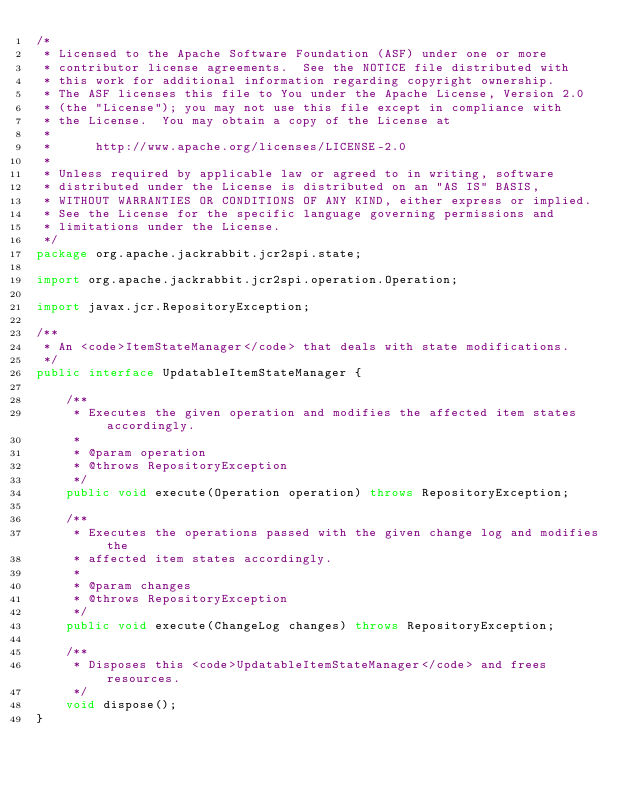Convert code to text. <code><loc_0><loc_0><loc_500><loc_500><_Java_>/*
 * Licensed to the Apache Software Foundation (ASF) under one or more
 * contributor license agreements.  See the NOTICE file distributed with
 * this work for additional information regarding copyright ownership.
 * The ASF licenses this file to You under the Apache License, Version 2.0
 * (the "License"); you may not use this file except in compliance with
 * the License.  You may obtain a copy of the License at
 *
 *      http://www.apache.org/licenses/LICENSE-2.0
 *
 * Unless required by applicable law or agreed to in writing, software
 * distributed under the License is distributed on an "AS IS" BASIS,
 * WITHOUT WARRANTIES OR CONDITIONS OF ANY KIND, either express or implied.
 * See the License for the specific language governing permissions and
 * limitations under the License.
 */
package org.apache.jackrabbit.jcr2spi.state;

import org.apache.jackrabbit.jcr2spi.operation.Operation;

import javax.jcr.RepositoryException;

/**
 * An <code>ItemStateManager</code> that deals with state modifications.
 */
public interface UpdatableItemStateManager {

    /**
     * Executes the given operation and modifies the affected item states accordingly.
     *
     * @param operation
     * @throws RepositoryException
     */
    public void execute(Operation operation) throws RepositoryException;

    /**
     * Executes the operations passed with the given change log and modifies the
     * affected item states accordingly.
     *
     * @param changes
     * @throws RepositoryException
     */
    public void execute(ChangeLog changes) throws RepositoryException;

    /**
     * Disposes this <code>UpdatableItemStateManager</code> and frees resources.
     */
    void dispose();
}
</code> 